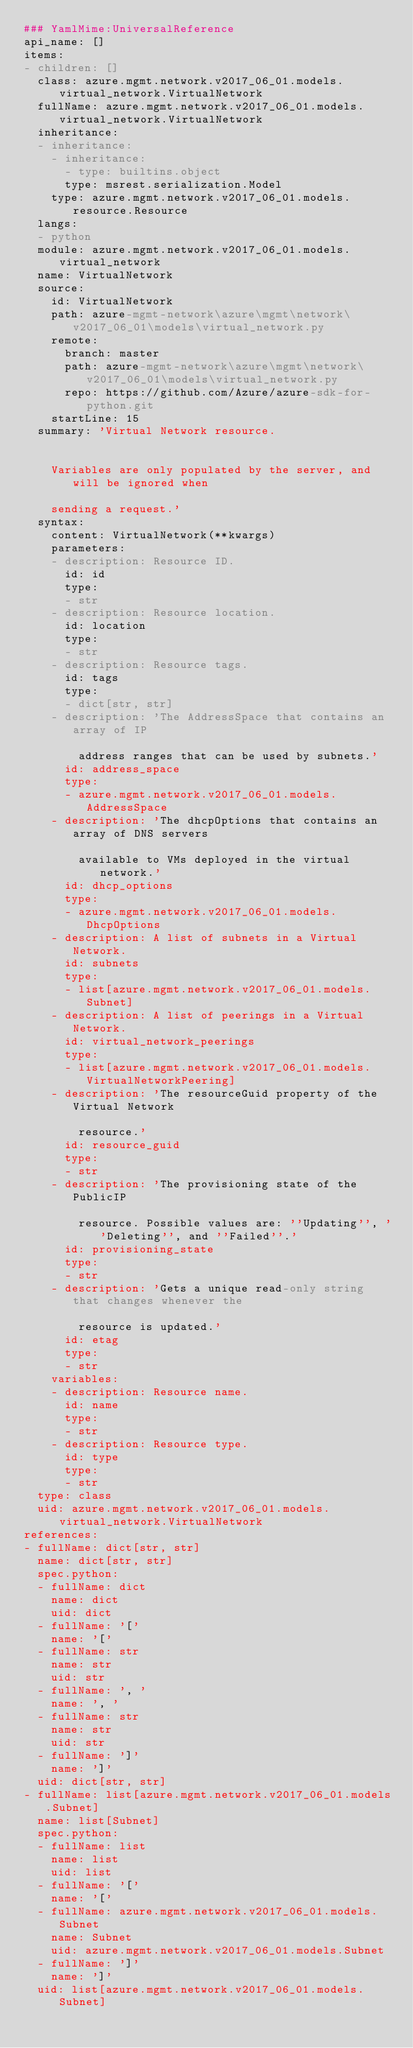<code> <loc_0><loc_0><loc_500><loc_500><_YAML_>### YamlMime:UniversalReference
api_name: []
items:
- children: []
  class: azure.mgmt.network.v2017_06_01.models.virtual_network.VirtualNetwork
  fullName: azure.mgmt.network.v2017_06_01.models.virtual_network.VirtualNetwork
  inheritance:
  - inheritance:
    - inheritance:
      - type: builtins.object
      type: msrest.serialization.Model
    type: azure.mgmt.network.v2017_06_01.models.resource.Resource
  langs:
  - python
  module: azure.mgmt.network.v2017_06_01.models.virtual_network
  name: VirtualNetwork
  source:
    id: VirtualNetwork
    path: azure-mgmt-network\azure\mgmt\network\v2017_06_01\models\virtual_network.py
    remote:
      branch: master
      path: azure-mgmt-network\azure\mgmt\network\v2017_06_01\models\virtual_network.py
      repo: https://github.com/Azure/azure-sdk-for-python.git
    startLine: 15
  summary: 'Virtual Network resource.


    Variables are only populated by the server, and will be ignored when

    sending a request.'
  syntax:
    content: VirtualNetwork(**kwargs)
    parameters:
    - description: Resource ID.
      id: id
      type:
      - str
    - description: Resource location.
      id: location
      type:
      - str
    - description: Resource tags.
      id: tags
      type:
      - dict[str, str]
    - description: 'The AddressSpace that contains an array of IP

        address ranges that can be used by subnets.'
      id: address_space
      type:
      - azure.mgmt.network.v2017_06_01.models.AddressSpace
    - description: 'The dhcpOptions that contains an array of DNS servers

        available to VMs deployed in the virtual network.'
      id: dhcp_options
      type:
      - azure.mgmt.network.v2017_06_01.models.DhcpOptions
    - description: A list of subnets in a Virtual Network.
      id: subnets
      type:
      - list[azure.mgmt.network.v2017_06_01.models.Subnet]
    - description: A list of peerings in a Virtual Network.
      id: virtual_network_peerings
      type:
      - list[azure.mgmt.network.v2017_06_01.models.VirtualNetworkPeering]
    - description: 'The resourceGuid property of the Virtual Network

        resource.'
      id: resource_guid
      type:
      - str
    - description: 'The provisioning state of the PublicIP

        resource. Possible values are: ''Updating'', ''Deleting'', and ''Failed''.'
      id: provisioning_state
      type:
      - str
    - description: 'Gets a unique read-only string that changes whenever the

        resource is updated.'
      id: etag
      type:
      - str
    variables:
    - description: Resource name.
      id: name
      type:
      - str
    - description: Resource type.
      id: type
      type:
      - str
  type: class
  uid: azure.mgmt.network.v2017_06_01.models.virtual_network.VirtualNetwork
references:
- fullName: dict[str, str]
  name: dict[str, str]
  spec.python:
  - fullName: dict
    name: dict
    uid: dict
  - fullName: '['
    name: '['
  - fullName: str
    name: str
    uid: str
  - fullName: ', '
    name: ', '
  - fullName: str
    name: str
    uid: str
  - fullName: ']'
    name: ']'
  uid: dict[str, str]
- fullName: list[azure.mgmt.network.v2017_06_01.models.Subnet]
  name: list[Subnet]
  spec.python:
  - fullName: list
    name: list
    uid: list
  - fullName: '['
    name: '['
  - fullName: azure.mgmt.network.v2017_06_01.models.Subnet
    name: Subnet
    uid: azure.mgmt.network.v2017_06_01.models.Subnet
  - fullName: ']'
    name: ']'
  uid: list[azure.mgmt.network.v2017_06_01.models.Subnet]</code> 